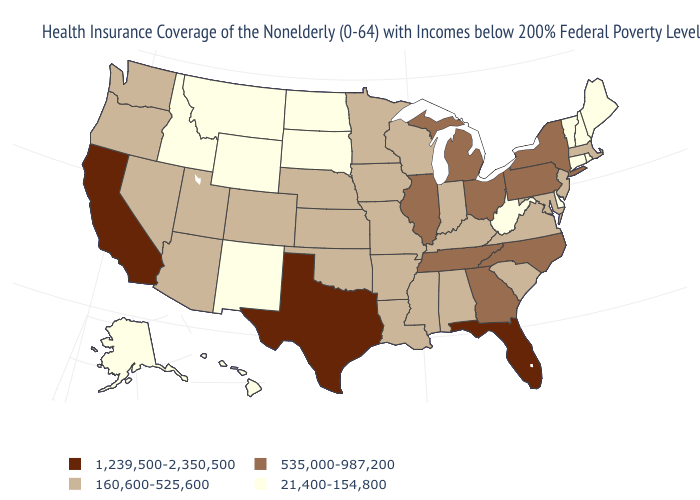Does Mississippi have the highest value in the USA?
Be succinct. No. Name the states that have a value in the range 535,000-987,200?
Be succinct. Georgia, Illinois, Michigan, New York, North Carolina, Ohio, Pennsylvania, Tennessee. Among the states that border Kansas , which have the highest value?
Answer briefly. Colorado, Missouri, Nebraska, Oklahoma. Name the states that have a value in the range 21,400-154,800?
Give a very brief answer. Alaska, Connecticut, Delaware, Hawaii, Idaho, Maine, Montana, New Hampshire, New Mexico, North Dakota, Rhode Island, South Dakota, Vermont, West Virginia, Wyoming. Name the states that have a value in the range 1,239,500-2,350,500?
Concise answer only. California, Florida, Texas. Does New Jersey have the lowest value in the Northeast?
Answer briefly. No. What is the value of North Dakota?
Concise answer only. 21,400-154,800. Does California have the highest value in the USA?
Short answer required. Yes. Name the states that have a value in the range 535,000-987,200?
Answer briefly. Georgia, Illinois, Michigan, New York, North Carolina, Ohio, Pennsylvania, Tennessee. What is the lowest value in the USA?
Keep it brief. 21,400-154,800. What is the value of California?
Keep it brief. 1,239,500-2,350,500. What is the lowest value in states that border Iowa?
Give a very brief answer. 21,400-154,800. What is the highest value in the Northeast ?
Keep it brief. 535,000-987,200. Does Colorado have a higher value than Minnesota?
Give a very brief answer. No. What is the value of Utah?
Concise answer only. 160,600-525,600. 